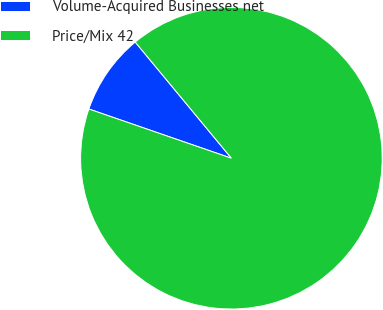Convert chart. <chart><loc_0><loc_0><loc_500><loc_500><pie_chart><fcel>Volume-Acquired Businesses net<fcel>Price/Mix 42<nl><fcel>8.7%<fcel>91.3%<nl></chart> 